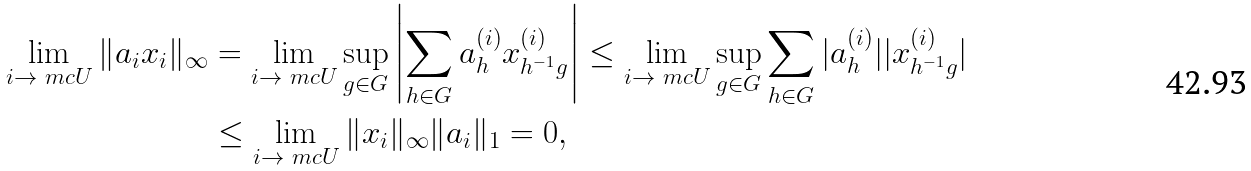<formula> <loc_0><loc_0><loc_500><loc_500>\lim _ { i \rightarrow \ m c U } \| a _ { i } x _ { i } \| _ { \infty } & = \lim _ { i \rightarrow \ m c U } \sup _ { g \in G } \left | \sum _ { h \in G } a ^ { ( i ) } _ { h } x ^ { ( i ) } _ { h ^ { - 1 } g } \right | \leq \lim _ { i \rightarrow \ m c U } \sup _ { g \in G } \sum _ { h \in G } | a ^ { ( i ) } _ { h } | | x ^ { ( i ) } _ { h ^ { - 1 } g } | \\ & \leq \lim _ { i \rightarrow \ m c U } \| x _ { i } \| _ { \infty } \| a _ { i } \| _ { 1 } = 0 ,</formula> 